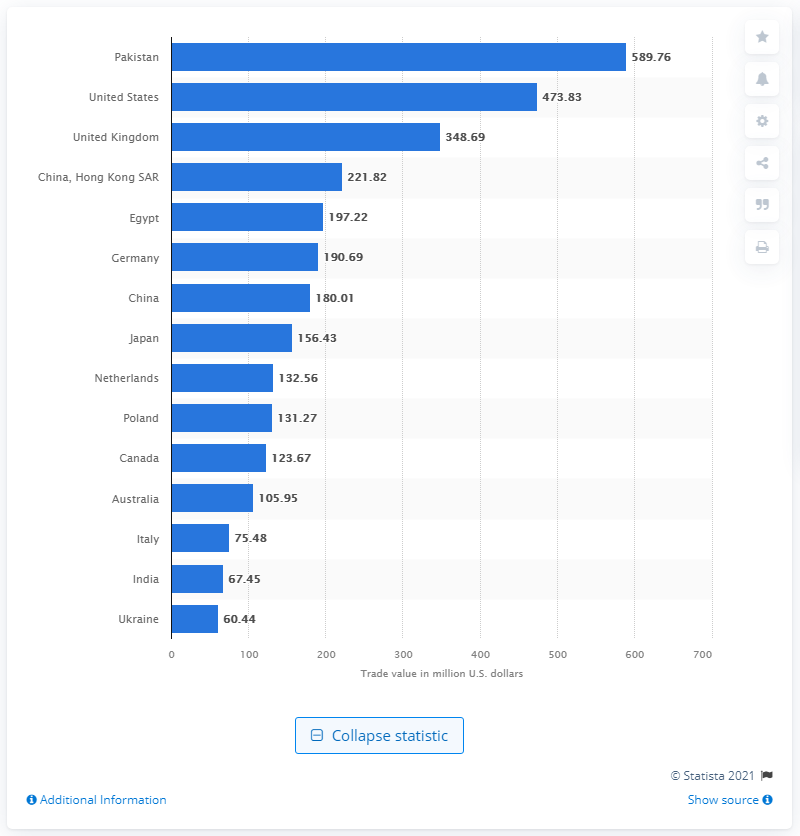Which country was the leading tea importer in the world in 2020? As of the latest available data from 2020, the leading country in terms of tea importation is not Pakistan. According to the image, which appears to show a bar chart from Statista, the United States was the top tea importer, with an import value of approximately 589.76 million U.S. dollars. 